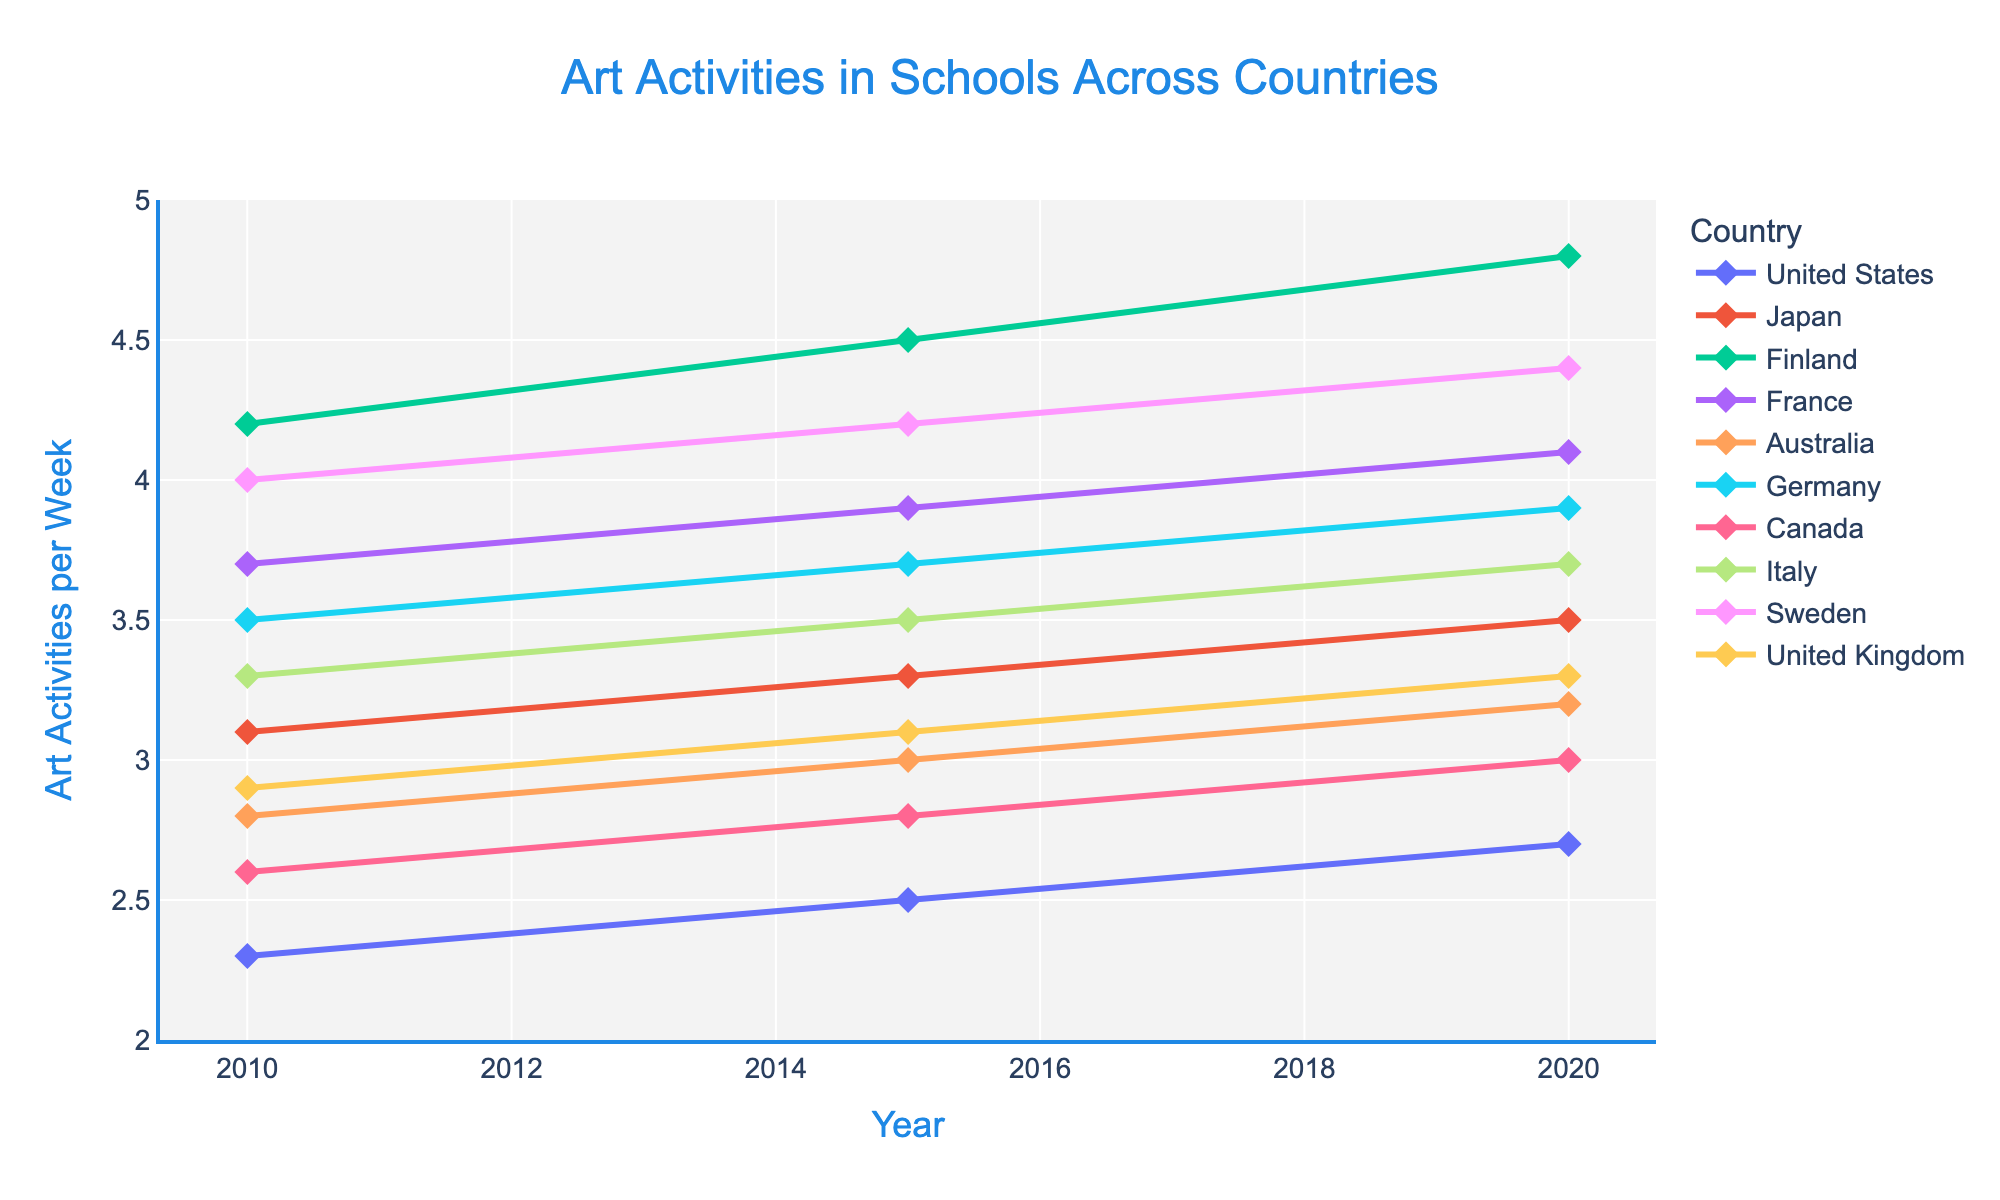Which country had the highest frequency of art activities per week in 2020? From the visual, Finland has the highest line marker in 2020, above the 4.5 mark
Answer: Finland What is the average number of art activities per week in the United States across all the years shown? Sum the values for the United States (2.3 + 2.5 + 2.7) = 7.5, then divide by the number of years (3) to get the average
Answer: 2.5 How much did the frequency of art activities per week increase in Japan from 2010 to 2020? Subtract the 2010 value for Japan (3.1) from the 2020 value (3.5)
Answer: 0.4 What is the difference in art activities per week between Finland and Germany in 2020? Subtract Germany's 2020 value (3.9) from Finland’s 2020 value (4.8)
Answer: 0.9 Is the average number of art activities per week in 2015 higher in Finland or Japan? The 2015 value for Finland is 4.5 and for Japan is 3.3; Finland's value is higher
Answer: Finland Which year had the lowest frequency of art activities per week in Australia? The year 2010 shows the lowest marker for Australia at 2.8 activities per week
Answer: 2010 What is the median value of art activities per week for France across all years? The values for France are (3.7, 3.9, 4.1). The median value is the middle value in this sorted list
Answer: 3.9 Which country showed a consistent increase in art activities per week across all years? All countries in the plot show a consistent increase each progressive year
Answer: All countries 